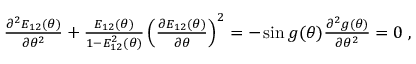Convert formula to latex. <formula><loc_0><loc_0><loc_500><loc_500>\begin{array} { r } { \frac { \partial ^ { 2 } E _ { 1 2 } ( \theta ) } { \partial \theta ^ { 2 } } + \frac { E _ { 1 2 } ( \theta ) } { 1 - E _ { 1 2 } ^ { 2 } ( \theta ) } \left ( \frac { \partial E _ { 1 2 } ( \theta ) } { \partial \theta } \right ) ^ { 2 } = - \sin g ( \theta ) \frac { \partial ^ { 2 } g ( \theta ) } { \partial \theta ^ { 2 } } = 0 \, , } \end{array}</formula> 